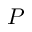<formula> <loc_0><loc_0><loc_500><loc_500>P</formula> 